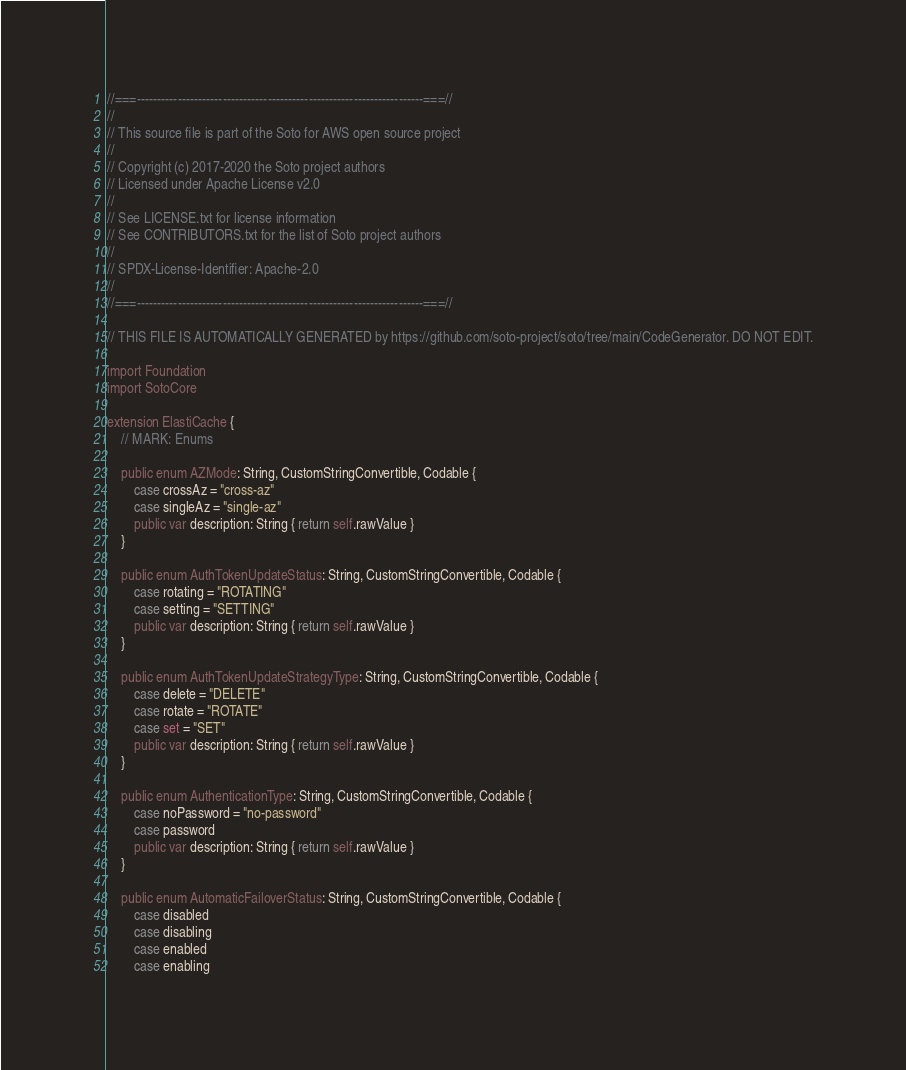<code> <loc_0><loc_0><loc_500><loc_500><_Swift_>//===----------------------------------------------------------------------===//
//
// This source file is part of the Soto for AWS open source project
//
// Copyright (c) 2017-2020 the Soto project authors
// Licensed under Apache License v2.0
//
// See LICENSE.txt for license information
// See CONTRIBUTORS.txt for the list of Soto project authors
//
// SPDX-License-Identifier: Apache-2.0
//
//===----------------------------------------------------------------------===//

// THIS FILE IS AUTOMATICALLY GENERATED by https://github.com/soto-project/soto/tree/main/CodeGenerator. DO NOT EDIT.

import Foundation
import SotoCore

extension ElastiCache {
    // MARK: Enums

    public enum AZMode: String, CustomStringConvertible, Codable {
        case crossAz = "cross-az"
        case singleAz = "single-az"
        public var description: String { return self.rawValue }
    }

    public enum AuthTokenUpdateStatus: String, CustomStringConvertible, Codable {
        case rotating = "ROTATING"
        case setting = "SETTING"
        public var description: String { return self.rawValue }
    }

    public enum AuthTokenUpdateStrategyType: String, CustomStringConvertible, Codable {
        case delete = "DELETE"
        case rotate = "ROTATE"
        case set = "SET"
        public var description: String { return self.rawValue }
    }

    public enum AuthenticationType: String, CustomStringConvertible, Codable {
        case noPassword = "no-password"
        case password
        public var description: String { return self.rawValue }
    }

    public enum AutomaticFailoverStatus: String, CustomStringConvertible, Codable {
        case disabled
        case disabling
        case enabled
        case enabling</code> 